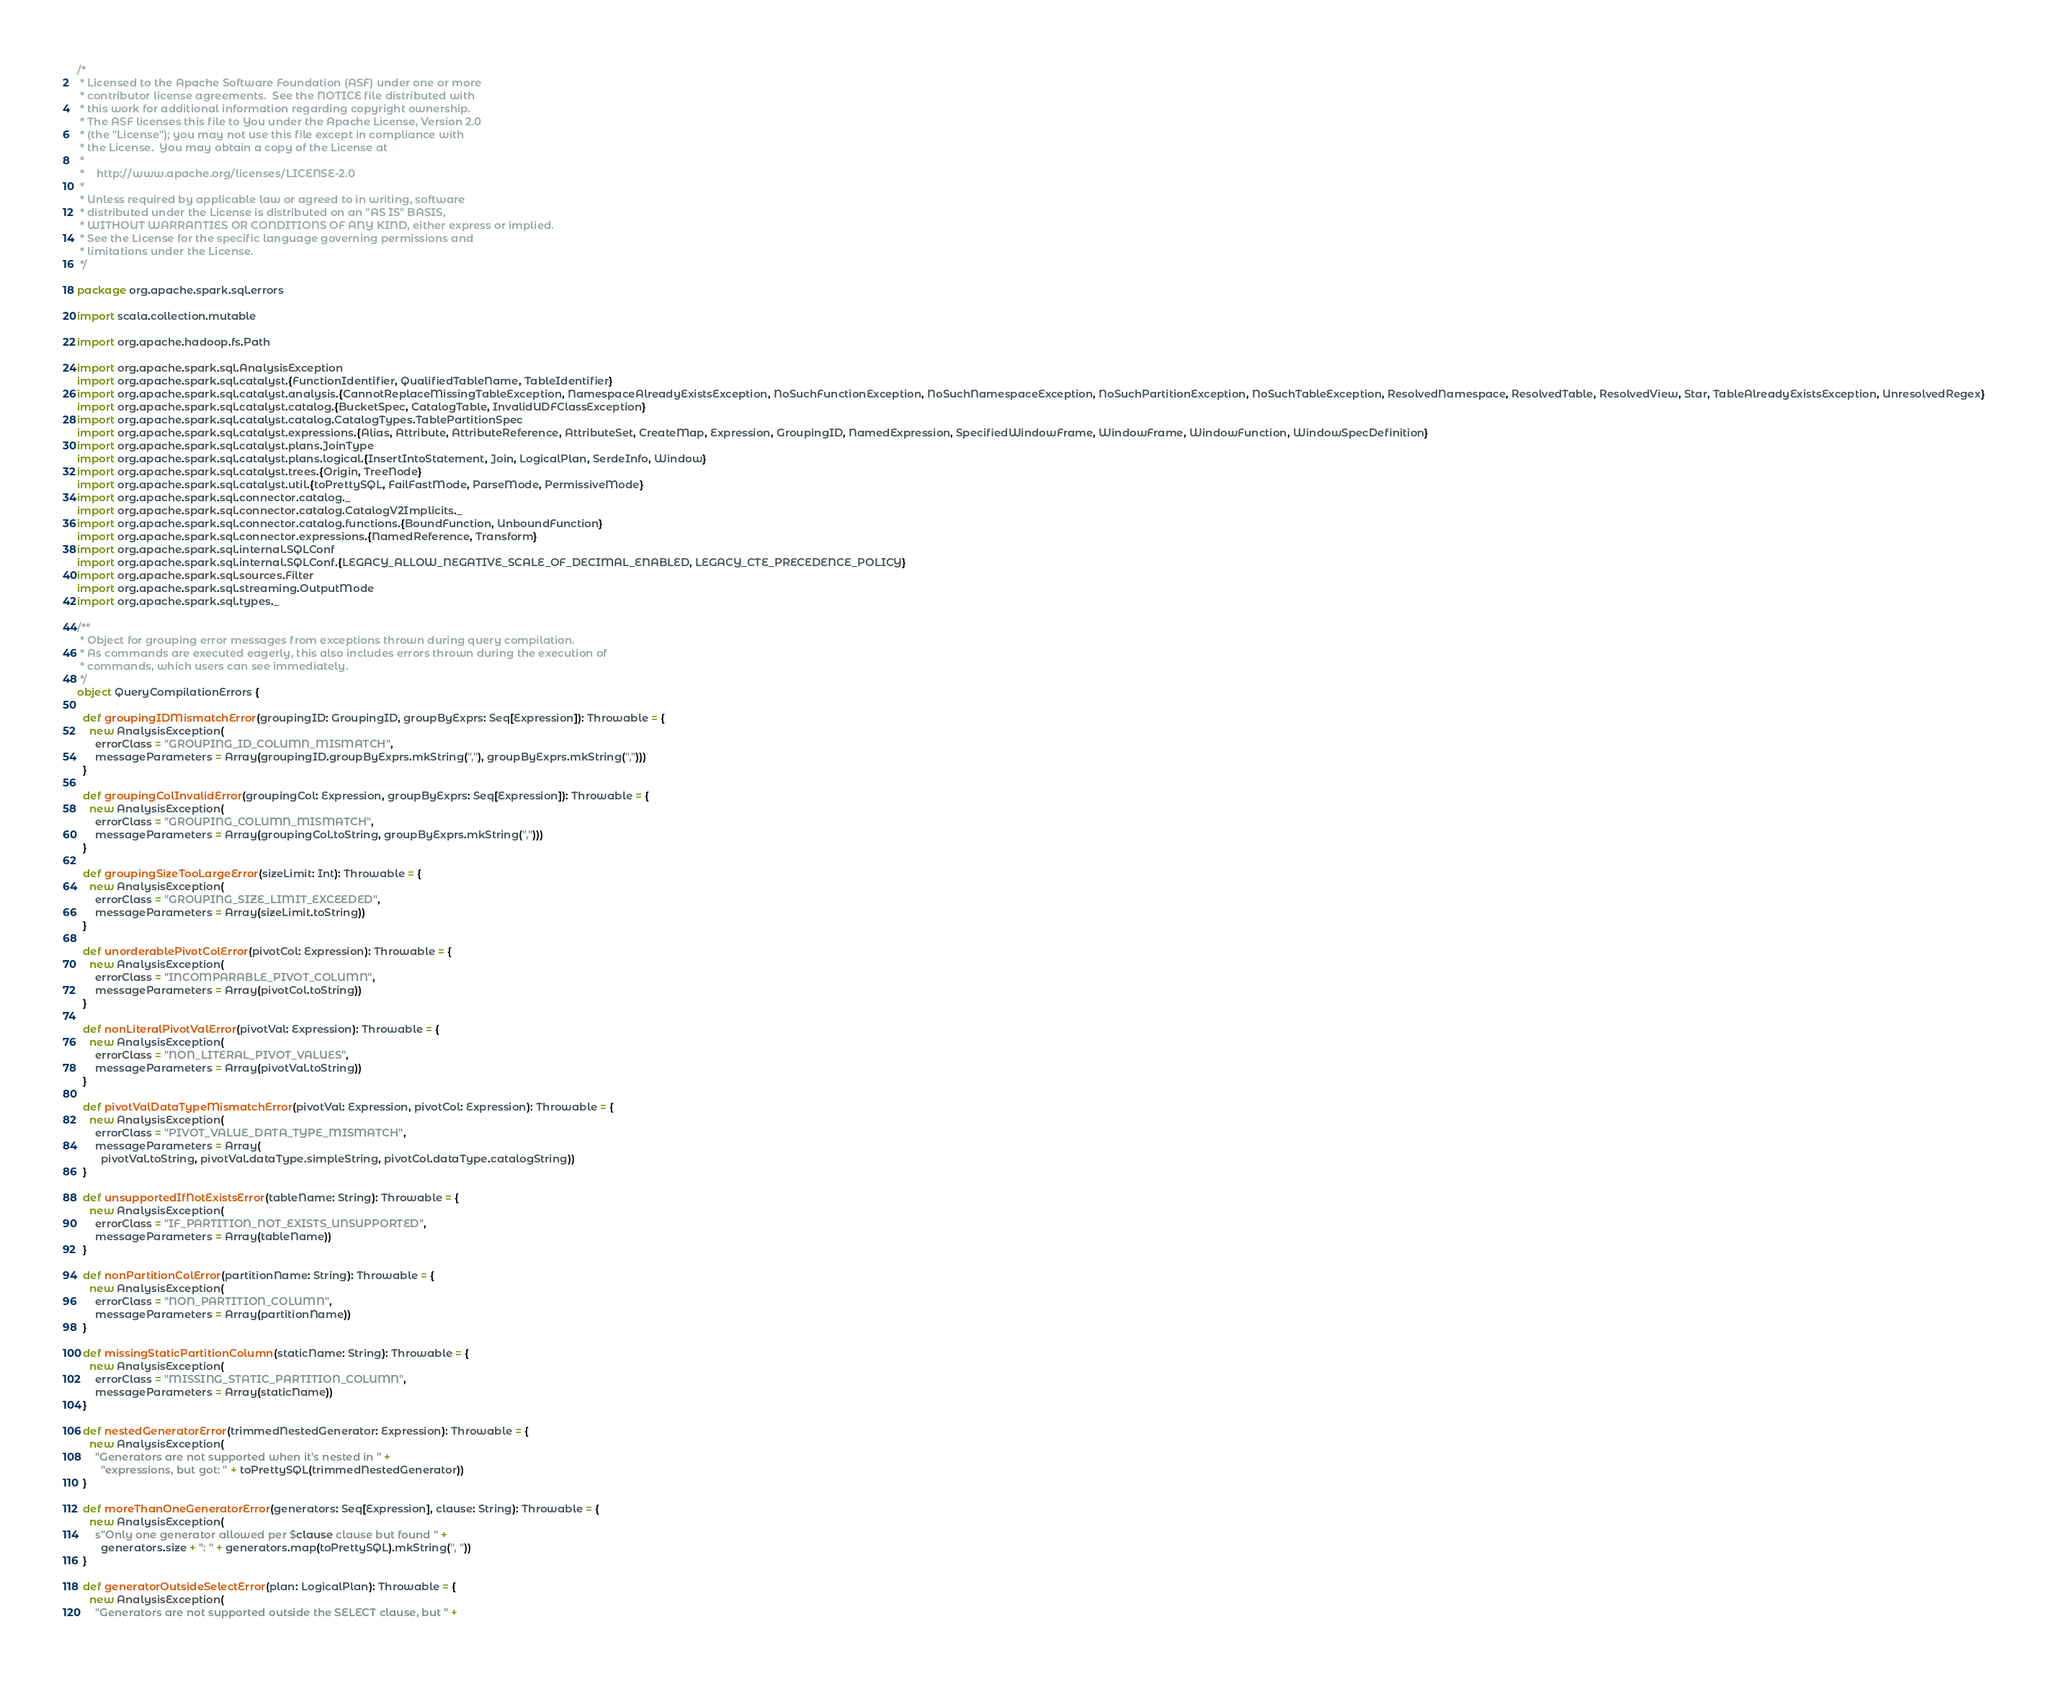<code> <loc_0><loc_0><loc_500><loc_500><_Scala_>/*
 * Licensed to the Apache Software Foundation (ASF) under one or more
 * contributor license agreements.  See the NOTICE file distributed with
 * this work for additional information regarding copyright ownership.
 * The ASF licenses this file to You under the Apache License, Version 2.0
 * (the "License"); you may not use this file except in compliance with
 * the License.  You may obtain a copy of the License at
 *
 *    http://www.apache.org/licenses/LICENSE-2.0
 *
 * Unless required by applicable law or agreed to in writing, software
 * distributed under the License is distributed on an "AS IS" BASIS,
 * WITHOUT WARRANTIES OR CONDITIONS OF ANY KIND, either express or implied.
 * See the License for the specific language governing permissions and
 * limitations under the License.
 */

package org.apache.spark.sql.errors

import scala.collection.mutable

import org.apache.hadoop.fs.Path

import org.apache.spark.sql.AnalysisException
import org.apache.spark.sql.catalyst.{FunctionIdentifier, QualifiedTableName, TableIdentifier}
import org.apache.spark.sql.catalyst.analysis.{CannotReplaceMissingTableException, NamespaceAlreadyExistsException, NoSuchFunctionException, NoSuchNamespaceException, NoSuchPartitionException, NoSuchTableException, ResolvedNamespace, ResolvedTable, ResolvedView, Star, TableAlreadyExistsException, UnresolvedRegex}
import org.apache.spark.sql.catalyst.catalog.{BucketSpec, CatalogTable, InvalidUDFClassException}
import org.apache.spark.sql.catalyst.catalog.CatalogTypes.TablePartitionSpec
import org.apache.spark.sql.catalyst.expressions.{Alias, Attribute, AttributeReference, AttributeSet, CreateMap, Expression, GroupingID, NamedExpression, SpecifiedWindowFrame, WindowFrame, WindowFunction, WindowSpecDefinition}
import org.apache.spark.sql.catalyst.plans.JoinType
import org.apache.spark.sql.catalyst.plans.logical.{InsertIntoStatement, Join, LogicalPlan, SerdeInfo, Window}
import org.apache.spark.sql.catalyst.trees.{Origin, TreeNode}
import org.apache.spark.sql.catalyst.util.{toPrettySQL, FailFastMode, ParseMode, PermissiveMode}
import org.apache.spark.sql.connector.catalog._
import org.apache.spark.sql.connector.catalog.CatalogV2Implicits._
import org.apache.spark.sql.connector.catalog.functions.{BoundFunction, UnboundFunction}
import org.apache.spark.sql.connector.expressions.{NamedReference, Transform}
import org.apache.spark.sql.internal.SQLConf
import org.apache.spark.sql.internal.SQLConf.{LEGACY_ALLOW_NEGATIVE_SCALE_OF_DECIMAL_ENABLED, LEGACY_CTE_PRECEDENCE_POLICY}
import org.apache.spark.sql.sources.Filter
import org.apache.spark.sql.streaming.OutputMode
import org.apache.spark.sql.types._

/**
 * Object for grouping error messages from exceptions thrown during query compilation.
 * As commands are executed eagerly, this also includes errors thrown during the execution of
 * commands, which users can see immediately.
 */
object QueryCompilationErrors {

  def groupingIDMismatchError(groupingID: GroupingID, groupByExprs: Seq[Expression]): Throwable = {
    new AnalysisException(
      errorClass = "GROUPING_ID_COLUMN_MISMATCH",
      messageParameters = Array(groupingID.groupByExprs.mkString(","), groupByExprs.mkString(",")))
  }

  def groupingColInvalidError(groupingCol: Expression, groupByExprs: Seq[Expression]): Throwable = {
    new AnalysisException(
      errorClass = "GROUPING_COLUMN_MISMATCH",
      messageParameters = Array(groupingCol.toString, groupByExprs.mkString(",")))
  }

  def groupingSizeTooLargeError(sizeLimit: Int): Throwable = {
    new AnalysisException(
      errorClass = "GROUPING_SIZE_LIMIT_EXCEEDED",
      messageParameters = Array(sizeLimit.toString))
  }

  def unorderablePivotColError(pivotCol: Expression): Throwable = {
    new AnalysisException(
      errorClass = "INCOMPARABLE_PIVOT_COLUMN",
      messageParameters = Array(pivotCol.toString))
  }

  def nonLiteralPivotValError(pivotVal: Expression): Throwable = {
    new AnalysisException(
      errorClass = "NON_LITERAL_PIVOT_VALUES",
      messageParameters = Array(pivotVal.toString))
  }

  def pivotValDataTypeMismatchError(pivotVal: Expression, pivotCol: Expression): Throwable = {
    new AnalysisException(
      errorClass = "PIVOT_VALUE_DATA_TYPE_MISMATCH",
      messageParameters = Array(
        pivotVal.toString, pivotVal.dataType.simpleString, pivotCol.dataType.catalogString))
  }

  def unsupportedIfNotExistsError(tableName: String): Throwable = {
    new AnalysisException(
      errorClass = "IF_PARTITION_NOT_EXISTS_UNSUPPORTED",
      messageParameters = Array(tableName))
  }

  def nonPartitionColError(partitionName: String): Throwable = {
    new AnalysisException(
      errorClass = "NON_PARTITION_COLUMN",
      messageParameters = Array(partitionName))
  }

  def missingStaticPartitionColumn(staticName: String): Throwable = {
    new AnalysisException(
      errorClass = "MISSING_STATIC_PARTITION_COLUMN",
      messageParameters = Array(staticName))
  }

  def nestedGeneratorError(trimmedNestedGenerator: Expression): Throwable = {
    new AnalysisException(
      "Generators are not supported when it's nested in " +
        "expressions, but got: " + toPrettySQL(trimmedNestedGenerator))
  }

  def moreThanOneGeneratorError(generators: Seq[Expression], clause: String): Throwable = {
    new AnalysisException(
      s"Only one generator allowed per $clause clause but found " +
        generators.size + ": " + generators.map(toPrettySQL).mkString(", "))
  }

  def generatorOutsideSelectError(plan: LogicalPlan): Throwable = {
    new AnalysisException(
      "Generators are not supported outside the SELECT clause, but " +</code> 